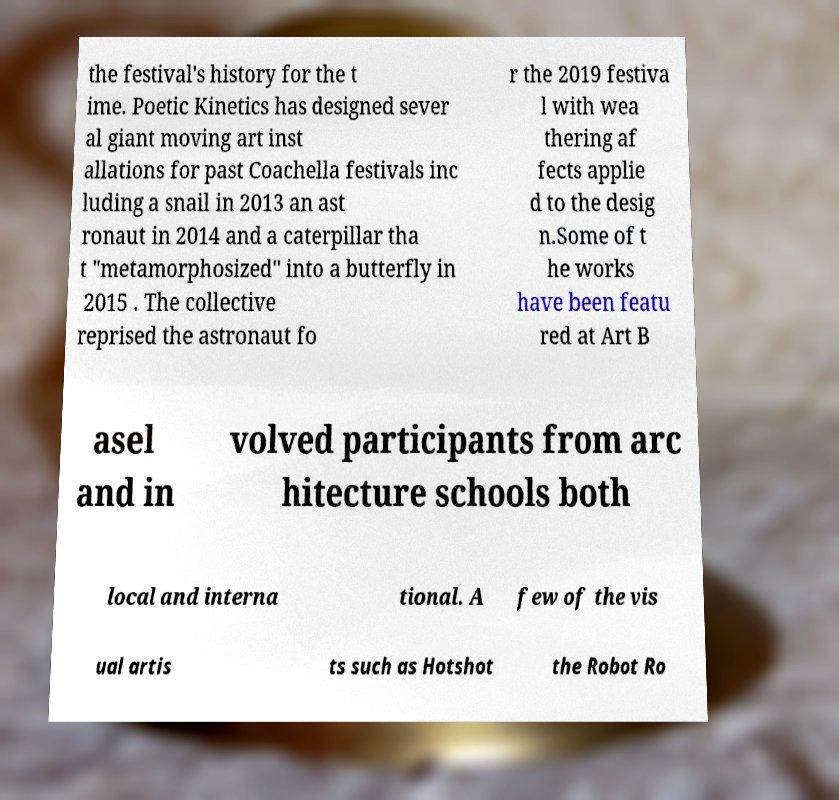There's text embedded in this image that I need extracted. Can you transcribe it verbatim? the festival's history for the t ime. Poetic Kinetics has designed sever al giant moving art inst allations for past Coachella festivals inc luding a snail in 2013 an ast ronaut in 2014 and a caterpillar tha t "metamorphosized" into a butterfly in 2015 . The collective reprised the astronaut fo r the 2019 festiva l with wea thering af fects applie d to the desig n.Some of t he works have been featu red at Art B asel and in volved participants from arc hitecture schools both local and interna tional. A few of the vis ual artis ts such as Hotshot the Robot Ro 